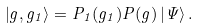<formula> <loc_0><loc_0><loc_500><loc_500>\left | g , g _ { 1 } \right > = P _ { 1 } ( g _ { 1 } ) P ( g ) \left | \Psi \right > .</formula> 